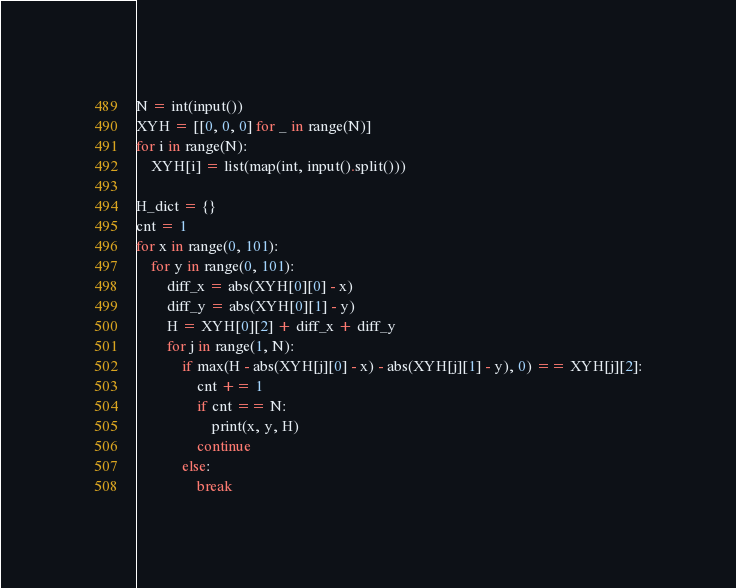<code> <loc_0><loc_0><loc_500><loc_500><_Python_>N = int(input())
XYH = [[0, 0, 0] for _ in range(N)]
for i in range(N):
    XYH[i] = list(map(int, input().split()))

H_dict = {}
cnt = 1
for x in range(0, 101):
    for y in range(0, 101):
        diff_x = abs(XYH[0][0] - x)
        diff_y = abs(XYH[0][1] - y)
        H = XYH[0][2] + diff_x + diff_y
        for j in range(1, N):
            if max(H - abs(XYH[j][0] - x) - abs(XYH[j][1] - y), 0) == XYH[j][2]:
                cnt += 1
                if cnt == N:
                    print(x, y, H)
                continue
            else:
                break
</code> 